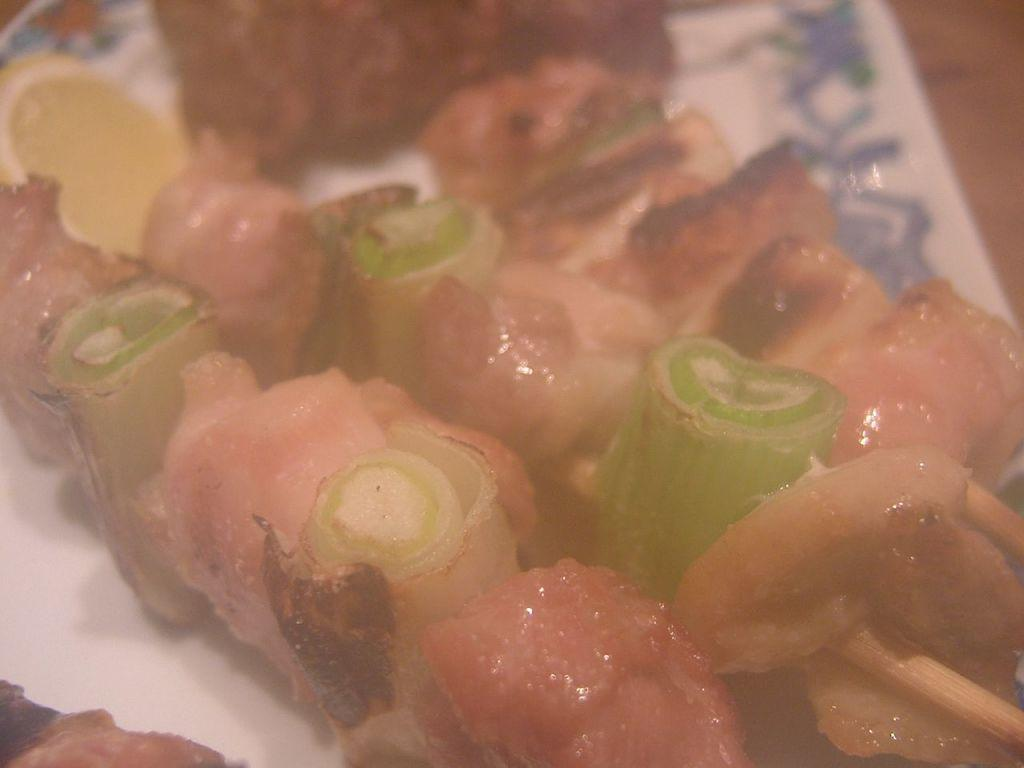What type of objects can be seen on the surface in the image? There are food items visible on a surface in the image. Can you describe the food items in more detail? Unfortunately, the provided facts do not give specific details about the food items. What might be the purpose of the surface where the food items are placed? The surface could be a table or countertop, and its purpose might be for serving or preparing food. How many leaves can be seen on the food items in the image? There are no leaves present on the food items in the image. What type of discovery can be made by examining the food items in the image? There is no discovery to be made by examining the food items in the image, as the provided facts do not suggest any unusual or unique characteristics about them. 